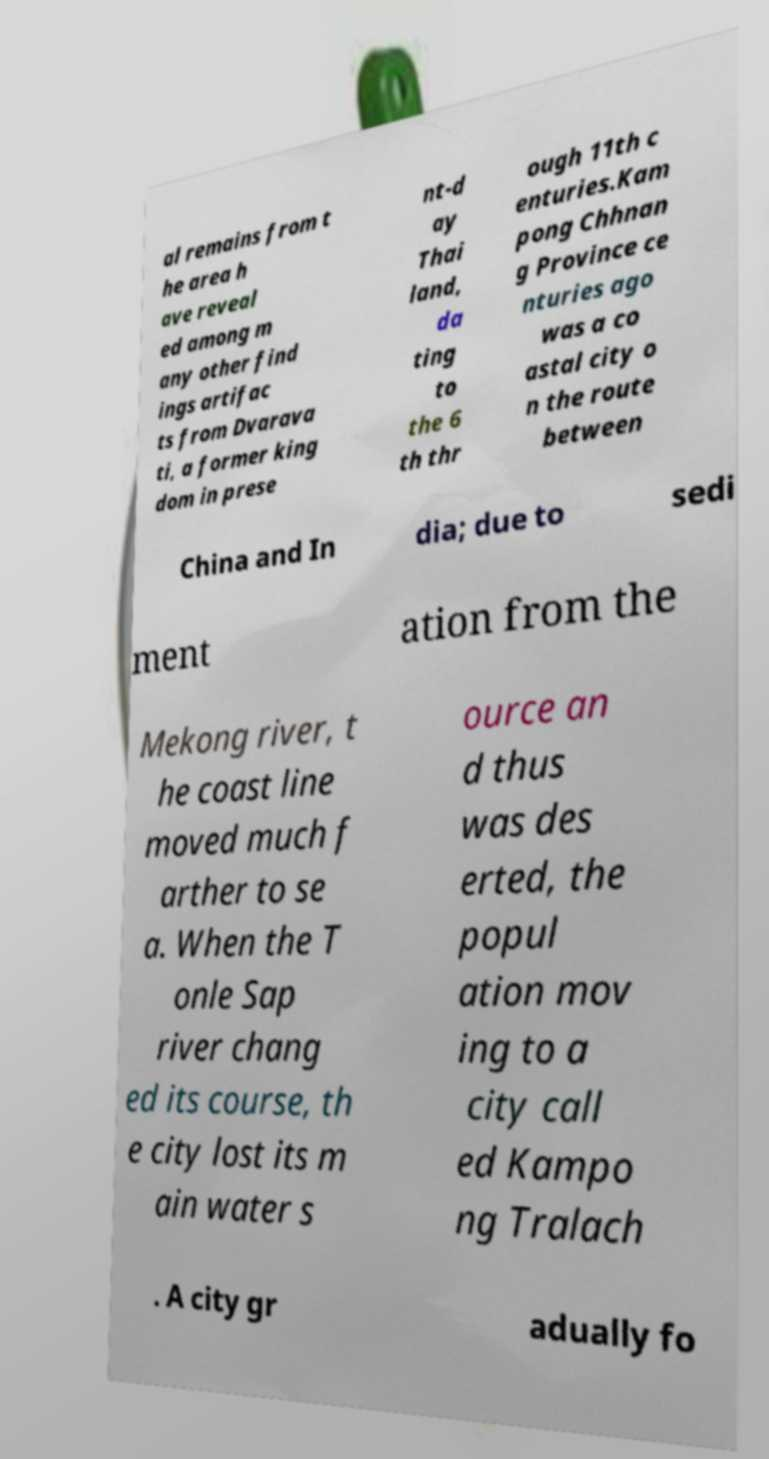Please identify and transcribe the text found in this image. al remains from t he area h ave reveal ed among m any other find ings artifac ts from Dvarava ti, a former king dom in prese nt-d ay Thai land, da ting to the 6 th thr ough 11th c enturies.Kam pong Chhnan g Province ce nturies ago was a co astal city o n the route between China and In dia; due to sedi ment ation from the Mekong river, t he coast line moved much f arther to se a. When the T onle Sap river chang ed its course, th e city lost its m ain water s ource an d thus was des erted, the popul ation mov ing to a city call ed Kampo ng Tralach . A city gr adually fo 